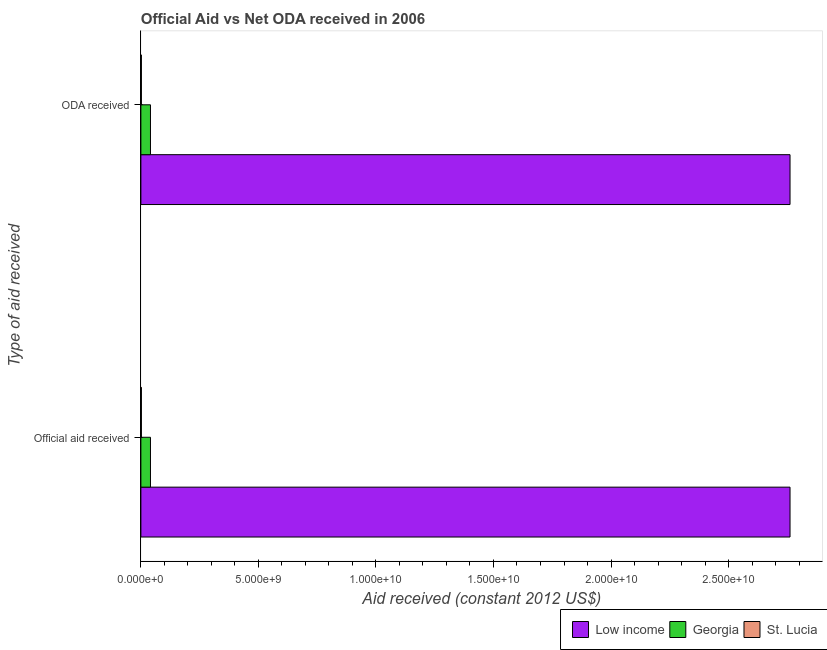How many different coloured bars are there?
Offer a very short reply. 3. How many groups of bars are there?
Provide a short and direct response. 2. Are the number of bars on each tick of the Y-axis equal?
Provide a short and direct response. Yes. How many bars are there on the 2nd tick from the bottom?
Your answer should be very brief. 3. What is the label of the 2nd group of bars from the top?
Offer a terse response. Official aid received. What is the official aid received in Georgia?
Make the answer very short. 4.07e+08. Across all countries, what is the maximum oda received?
Your answer should be very brief. 2.76e+1. Across all countries, what is the minimum official aid received?
Keep it short and to the point. 2.18e+07. In which country was the official aid received minimum?
Give a very brief answer. St. Lucia. What is the total oda received in the graph?
Offer a terse response. 2.80e+1. What is the difference between the official aid received in St. Lucia and that in Georgia?
Make the answer very short. -3.85e+08. What is the difference between the official aid received in St. Lucia and the oda received in Low income?
Your answer should be very brief. -2.76e+1. What is the average oda received per country?
Your answer should be very brief. 9.35e+09. What is the ratio of the oda received in Georgia to that in St. Lucia?
Give a very brief answer. 18.67. In how many countries, is the official aid received greater than the average official aid received taken over all countries?
Provide a short and direct response. 1. What does the 3rd bar from the top in ODA received represents?
Your answer should be compact. Low income. What does the 3rd bar from the bottom in ODA received represents?
Your answer should be very brief. St. Lucia. Are all the bars in the graph horizontal?
Give a very brief answer. Yes. How many countries are there in the graph?
Offer a very short reply. 3. Are the values on the major ticks of X-axis written in scientific E-notation?
Give a very brief answer. Yes. Does the graph contain any zero values?
Provide a short and direct response. No. Does the graph contain grids?
Ensure brevity in your answer.  No. Where does the legend appear in the graph?
Your answer should be very brief. Bottom right. How many legend labels are there?
Offer a very short reply. 3. What is the title of the graph?
Provide a succinct answer. Official Aid vs Net ODA received in 2006 . Does "Swaziland" appear as one of the legend labels in the graph?
Keep it short and to the point. No. What is the label or title of the X-axis?
Your answer should be very brief. Aid received (constant 2012 US$). What is the label or title of the Y-axis?
Offer a terse response. Type of aid received. What is the Aid received (constant 2012 US$) of Low income in Official aid received?
Keep it short and to the point. 2.76e+1. What is the Aid received (constant 2012 US$) of Georgia in Official aid received?
Ensure brevity in your answer.  4.07e+08. What is the Aid received (constant 2012 US$) in St. Lucia in Official aid received?
Offer a very short reply. 2.18e+07. What is the Aid received (constant 2012 US$) of Low income in ODA received?
Make the answer very short. 2.76e+1. What is the Aid received (constant 2012 US$) in Georgia in ODA received?
Your answer should be compact. 4.07e+08. What is the Aid received (constant 2012 US$) in St. Lucia in ODA received?
Keep it short and to the point. 2.18e+07. Across all Type of aid received, what is the maximum Aid received (constant 2012 US$) in Low income?
Ensure brevity in your answer.  2.76e+1. Across all Type of aid received, what is the maximum Aid received (constant 2012 US$) of Georgia?
Keep it short and to the point. 4.07e+08. Across all Type of aid received, what is the maximum Aid received (constant 2012 US$) of St. Lucia?
Your response must be concise. 2.18e+07. Across all Type of aid received, what is the minimum Aid received (constant 2012 US$) of Low income?
Give a very brief answer. 2.76e+1. Across all Type of aid received, what is the minimum Aid received (constant 2012 US$) in Georgia?
Offer a terse response. 4.07e+08. Across all Type of aid received, what is the minimum Aid received (constant 2012 US$) of St. Lucia?
Offer a very short reply. 2.18e+07. What is the total Aid received (constant 2012 US$) in Low income in the graph?
Give a very brief answer. 5.52e+1. What is the total Aid received (constant 2012 US$) in Georgia in the graph?
Your answer should be compact. 8.15e+08. What is the total Aid received (constant 2012 US$) of St. Lucia in the graph?
Your answer should be very brief. 4.36e+07. What is the difference between the Aid received (constant 2012 US$) in Low income in Official aid received and that in ODA received?
Your response must be concise. 0. What is the difference between the Aid received (constant 2012 US$) in Georgia in Official aid received and that in ODA received?
Keep it short and to the point. 0. What is the difference between the Aid received (constant 2012 US$) of Low income in Official aid received and the Aid received (constant 2012 US$) of Georgia in ODA received?
Your answer should be very brief. 2.72e+1. What is the difference between the Aid received (constant 2012 US$) in Low income in Official aid received and the Aid received (constant 2012 US$) in St. Lucia in ODA received?
Provide a short and direct response. 2.76e+1. What is the difference between the Aid received (constant 2012 US$) of Georgia in Official aid received and the Aid received (constant 2012 US$) of St. Lucia in ODA received?
Provide a short and direct response. 3.85e+08. What is the average Aid received (constant 2012 US$) in Low income per Type of aid received?
Your answer should be very brief. 2.76e+1. What is the average Aid received (constant 2012 US$) in Georgia per Type of aid received?
Offer a very short reply. 4.07e+08. What is the average Aid received (constant 2012 US$) of St. Lucia per Type of aid received?
Your response must be concise. 2.18e+07. What is the difference between the Aid received (constant 2012 US$) in Low income and Aid received (constant 2012 US$) in Georgia in Official aid received?
Offer a terse response. 2.72e+1. What is the difference between the Aid received (constant 2012 US$) of Low income and Aid received (constant 2012 US$) of St. Lucia in Official aid received?
Your answer should be compact. 2.76e+1. What is the difference between the Aid received (constant 2012 US$) of Georgia and Aid received (constant 2012 US$) of St. Lucia in Official aid received?
Your answer should be compact. 3.85e+08. What is the difference between the Aid received (constant 2012 US$) of Low income and Aid received (constant 2012 US$) of Georgia in ODA received?
Provide a short and direct response. 2.72e+1. What is the difference between the Aid received (constant 2012 US$) in Low income and Aid received (constant 2012 US$) in St. Lucia in ODA received?
Your answer should be compact. 2.76e+1. What is the difference between the Aid received (constant 2012 US$) in Georgia and Aid received (constant 2012 US$) in St. Lucia in ODA received?
Make the answer very short. 3.85e+08. What is the ratio of the Aid received (constant 2012 US$) in St. Lucia in Official aid received to that in ODA received?
Offer a terse response. 1. What is the difference between the highest and the second highest Aid received (constant 2012 US$) of Low income?
Offer a terse response. 0. What is the difference between the highest and the second highest Aid received (constant 2012 US$) of Georgia?
Offer a very short reply. 0. What is the difference between the highest and the lowest Aid received (constant 2012 US$) in Low income?
Provide a succinct answer. 0. 